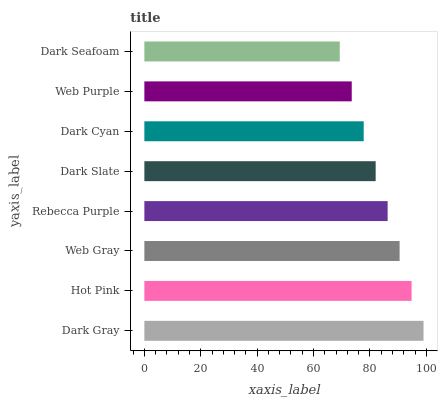Is Dark Seafoam the minimum?
Answer yes or no. Yes. Is Dark Gray the maximum?
Answer yes or no. Yes. Is Hot Pink the minimum?
Answer yes or no. No. Is Hot Pink the maximum?
Answer yes or no. No. Is Dark Gray greater than Hot Pink?
Answer yes or no. Yes. Is Hot Pink less than Dark Gray?
Answer yes or no. Yes. Is Hot Pink greater than Dark Gray?
Answer yes or no. No. Is Dark Gray less than Hot Pink?
Answer yes or no. No. Is Rebecca Purple the high median?
Answer yes or no. Yes. Is Dark Slate the low median?
Answer yes or no. Yes. Is Dark Slate the high median?
Answer yes or no. No. Is Web Gray the low median?
Answer yes or no. No. 